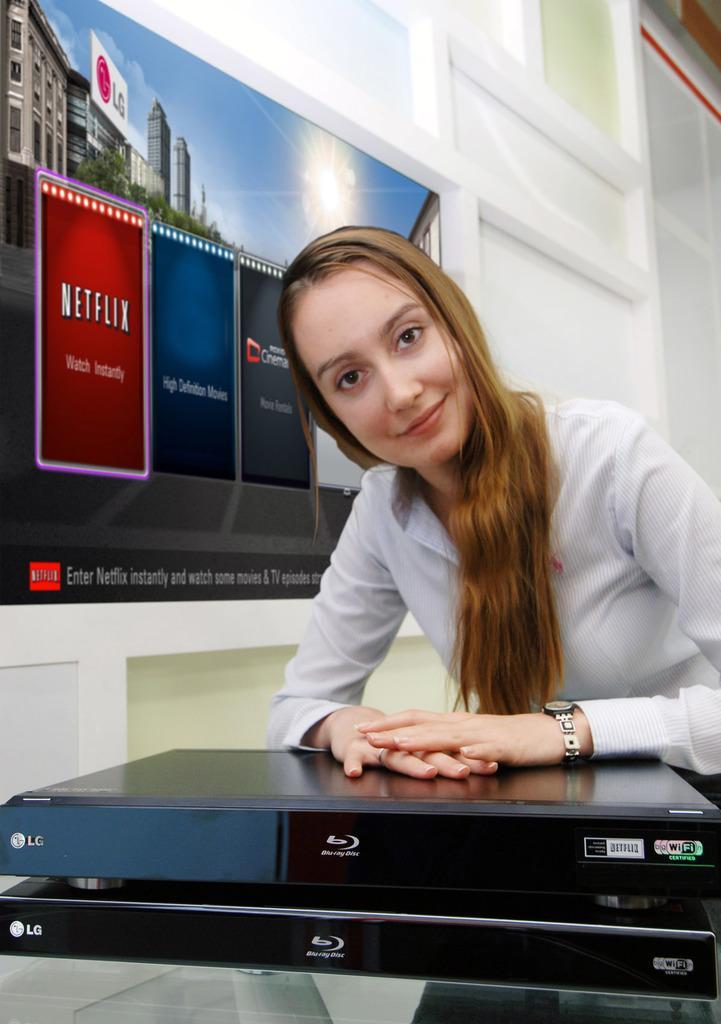Describe this image in one or two sentences. There is a woman smiling,in front of her we can see device. In the background we can see wall and screen. 